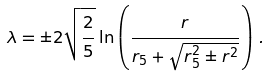Convert formula to latex. <formula><loc_0><loc_0><loc_500><loc_500>\lambda = \pm 2 \sqrt { \frac { 2 } { 5 } } \ln \left ( \frac { r } { r _ { 5 } + \sqrt { r _ { 5 } ^ { 2 } \pm r ^ { 2 } } } \right ) \, .</formula> 